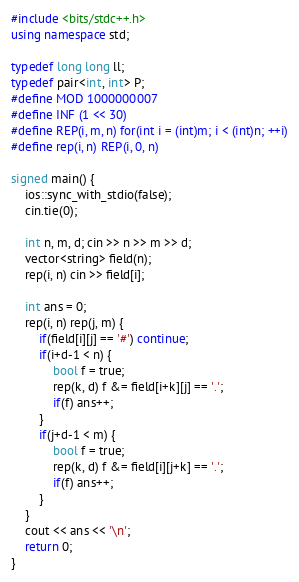Convert code to text. <code><loc_0><loc_0><loc_500><loc_500><_C++_>#include <bits/stdc++.h>
using namespace std;

typedef long long ll;
typedef pair<int, int> P;
#define MOD 1000000007
#define INF (1 << 30)
#define REP(i, m, n) for(int i = (int)m; i < (int)n; ++i)
#define rep(i, n) REP(i, 0, n)

signed main() {
    ios::sync_with_stdio(false);
    cin.tie(0);

    int n, m, d; cin >> n >> m >> d;
    vector<string> field(n);
    rep(i, n) cin >> field[i];

    int ans = 0;
    rep(i, n) rep(j, m) {
        if(field[i][j] == '#') continue;
        if(i+d-1 < n) {
            bool f = true;
            rep(k, d) f &= field[i+k][j] == '.';
            if(f) ans++;
        }
        if(j+d-1 < m) {
            bool f = true;
            rep(k, d) f &= field[i][j+k] == '.';
            if(f) ans++;
        }
    }
    cout << ans << '\n';
    return 0;
}
</code> 